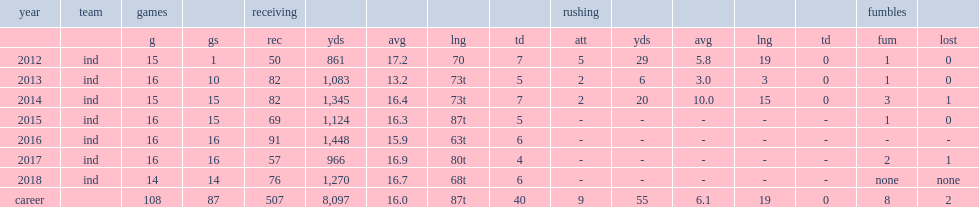How many yards did t. y. hilton have in the 2016 season? 1448.0. 